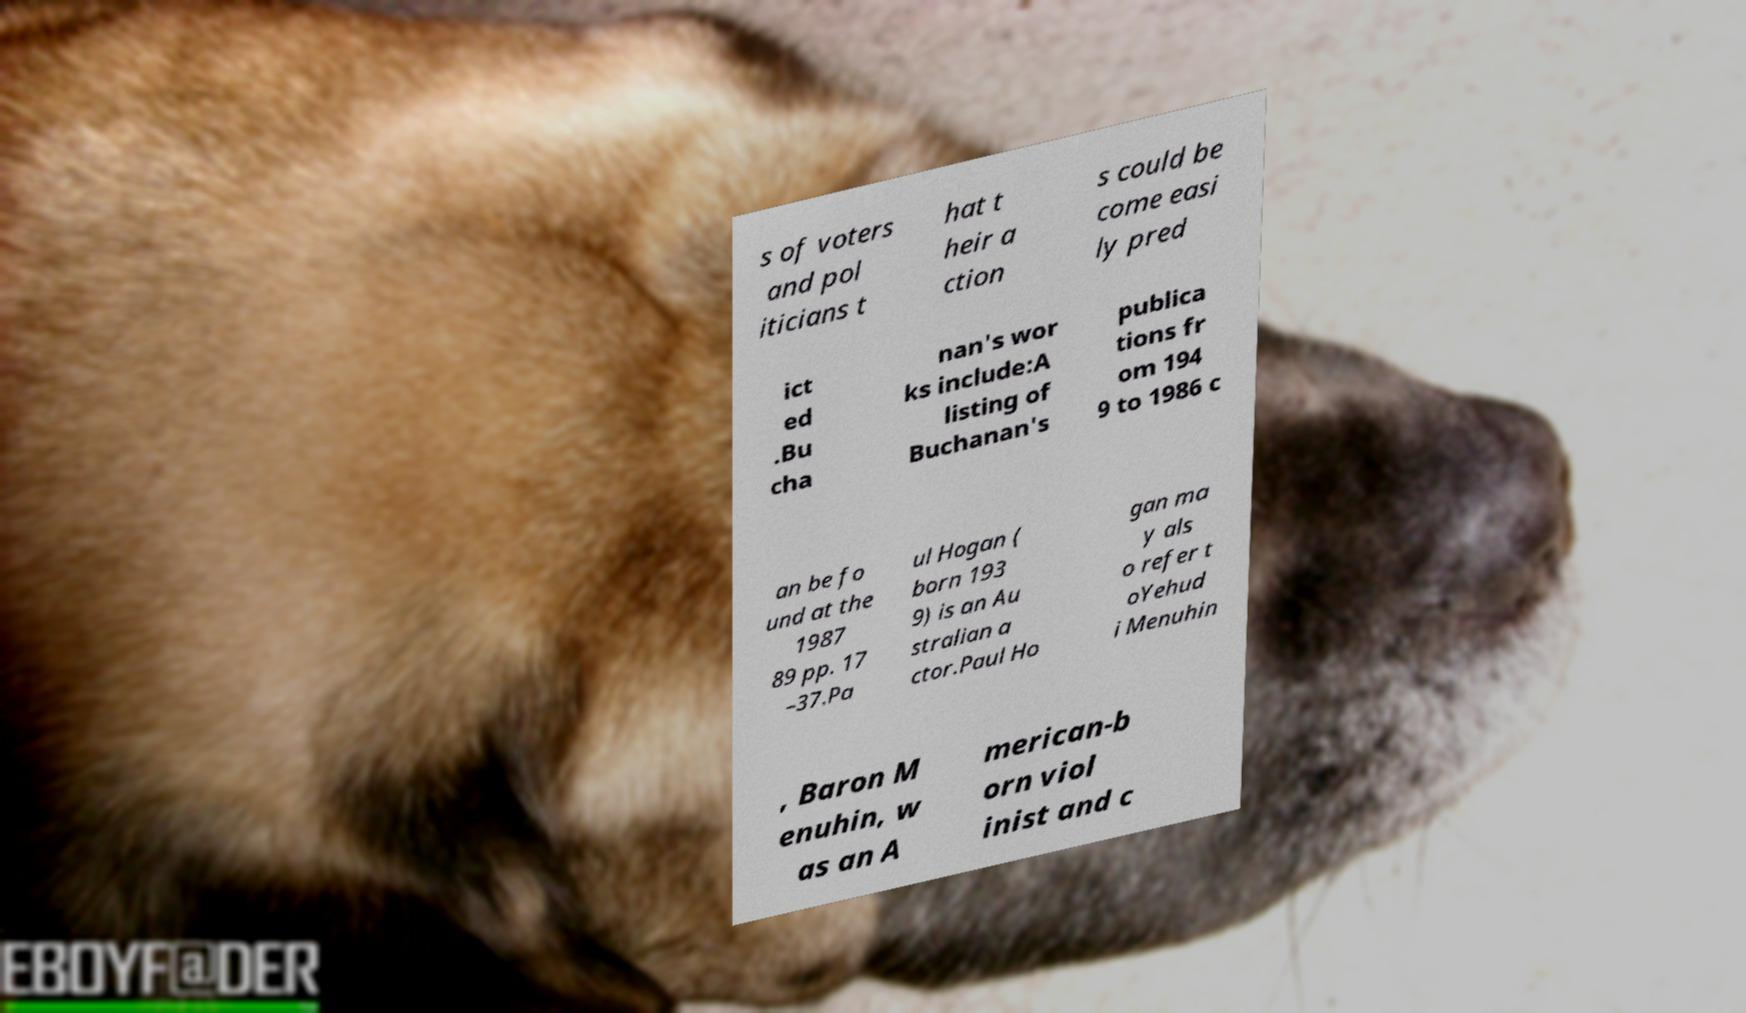Please identify and transcribe the text found in this image. s of voters and pol iticians t hat t heir a ction s could be come easi ly pred ict ed .Bu cha nan's wor ks include:A listing of Buchanan's publica tions fr om 194 9 to 1986 c an be fo und at the 1987 89 pp. 17 –37.Pa ul Hogan ( born 193 9) is an Au stralian a ctor.Paul Ho gan ma y als o refer t oYehud i Menuhin , Baron M enuhin, w as an A merican-b orn viol inist and c 